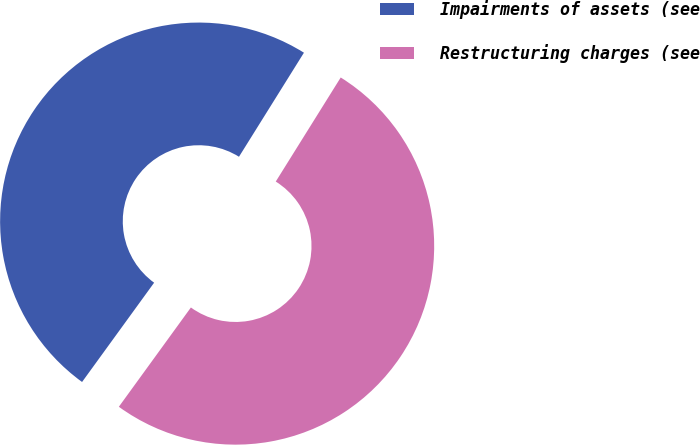Convert chart. <chart><loc_0><loc_0><loc_500><loc_500><pie_chart><fcel>Impairments of assets (see<fcel>Restructuring charges (see<nl><fcel>48.89%<fcel>51.11%<nl></chart> 